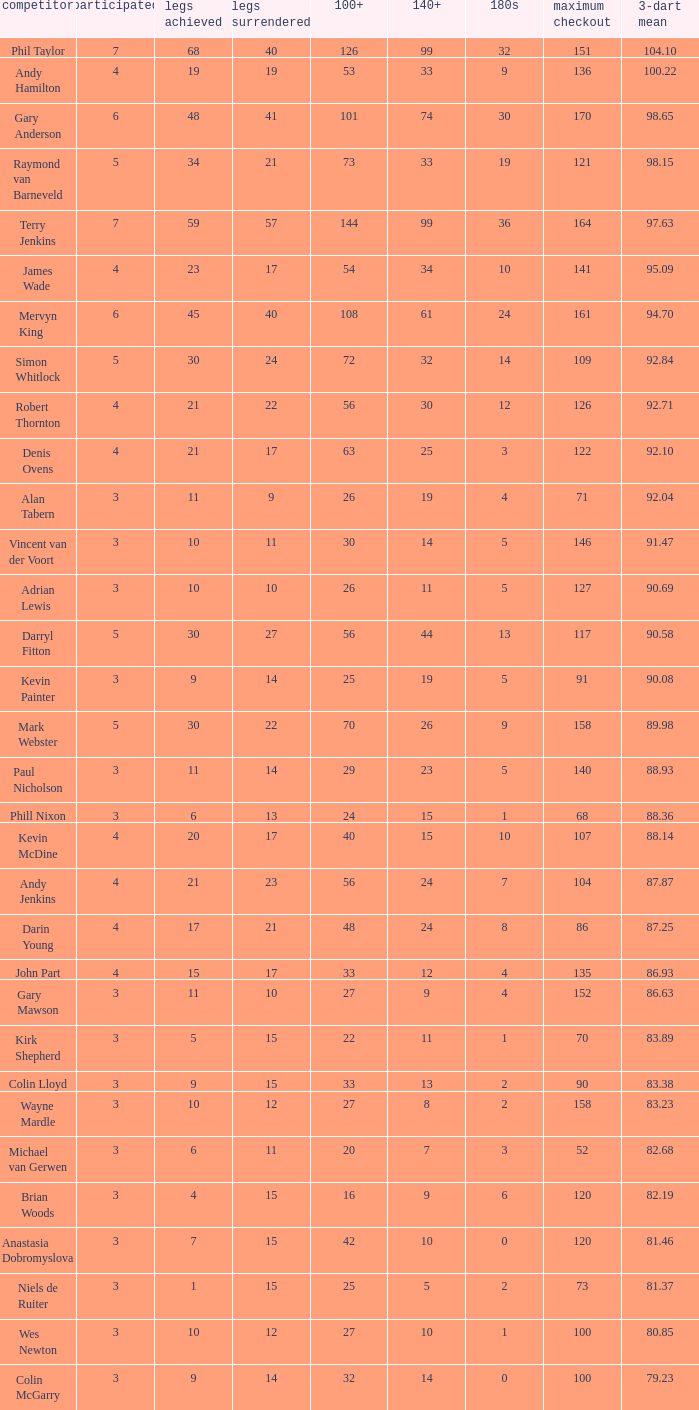What is the highest Legs Lost with a 180s larger than 1, a 100+ of 53, and played is smaller than 4? None. 